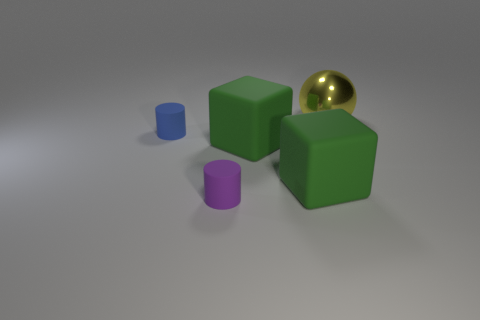How big is the shiny thing?
Give a very brief answer. Large. There is another small thing that is the same shape as the small blue object; what is its color?
Your answer should be compact. Purple. How many objects are either things that are in front of the yellow thing or yellow metallic things behind the blue cylinder?
Your response must be concise. 5. What is the shape of the large metal thing?
Keep it short and to the point. Sphere. What number of big blocks have the same material as the purple cylinder?
Make the answer very short. 2. What is the color of the shiny object?
Your response must be concise. Yellow. What is the color of the matte object that is the same size as the purple rubber cylinder?
Your answer should be compact. Blue. Are there any small spheres of the same color as the metallic object?
Offer a very short reply. No. Is the shape of the big shiny thing on the right side of the small blue cylinder the same as the small rubber thing to the right of the blue cylinder?
Offer a terse response. No. How many other objects are there of the same size as the blue cylinder?
Provide a succinct answer. 1. 